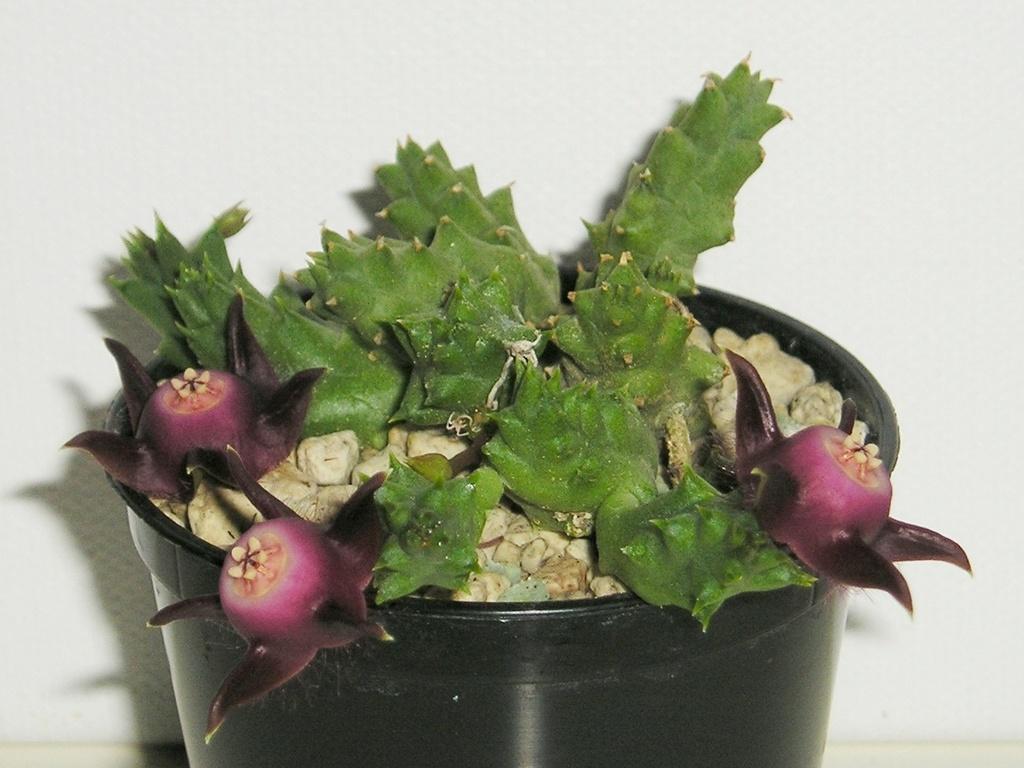Please provide a concise description of this image. In this image we can see a plant which is placed in a black color flower pot. 